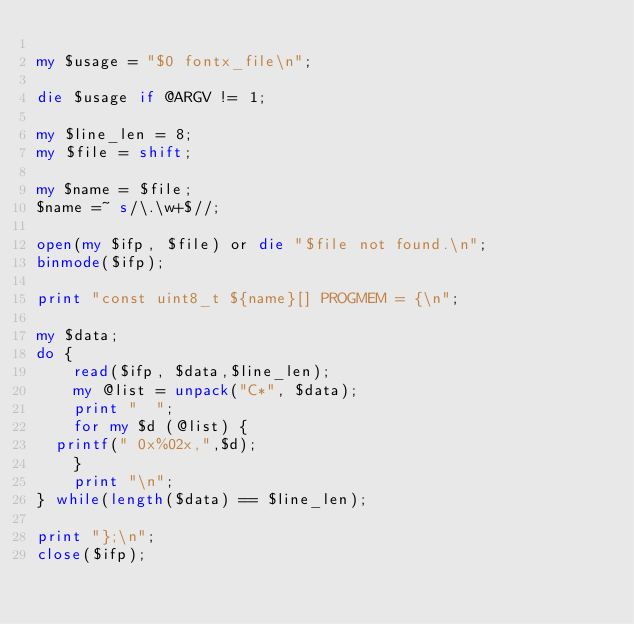Convert code to text. <code><loc_0><loc_0><loc_500><loc_500><_Perl_>
my $usage = "$0 fontx_file\n";

die $usage if @ARGV != 1;

my $line_len = 8;
my $file = shift;

my $name = $file;
$name =~ s/\.\w+$//;

open(my $ifp, $file) or die "$file not found.\n";
binmode($ifp);

print "const uint8_t ${name}[] PROGMEM = {\n";

my $data;
do {
    read($ifp, $data,$line_len);
    my @list = unpack("C*", $data);
    print "  ";
    for my $d (@list) {
	printf(" 0x%02x,",$d);
    }
    print "\n";
} while(length($data) == $line_len);

print "};\n";
close($ifp);

    
</code> 